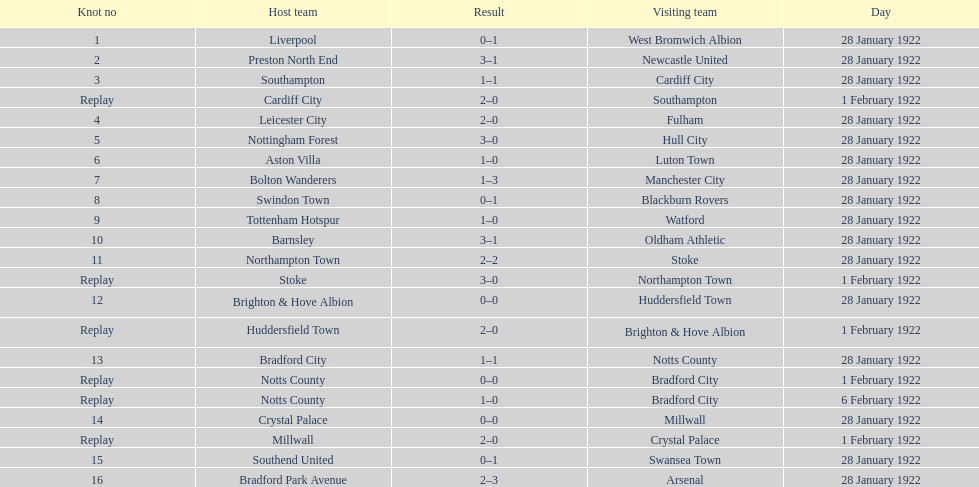How many games had four total points scored or more? 5. 